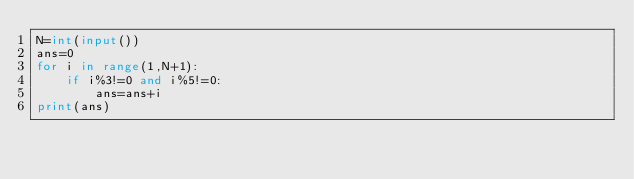<code> <loc_0><loc_0><loc_500><loc_500><_Python_>N=int(input())
ans=0
for i in range(1,N+1):
    if i%3!=0 and i%5!=0:
        ans=ans+i
print(ans)</code> 